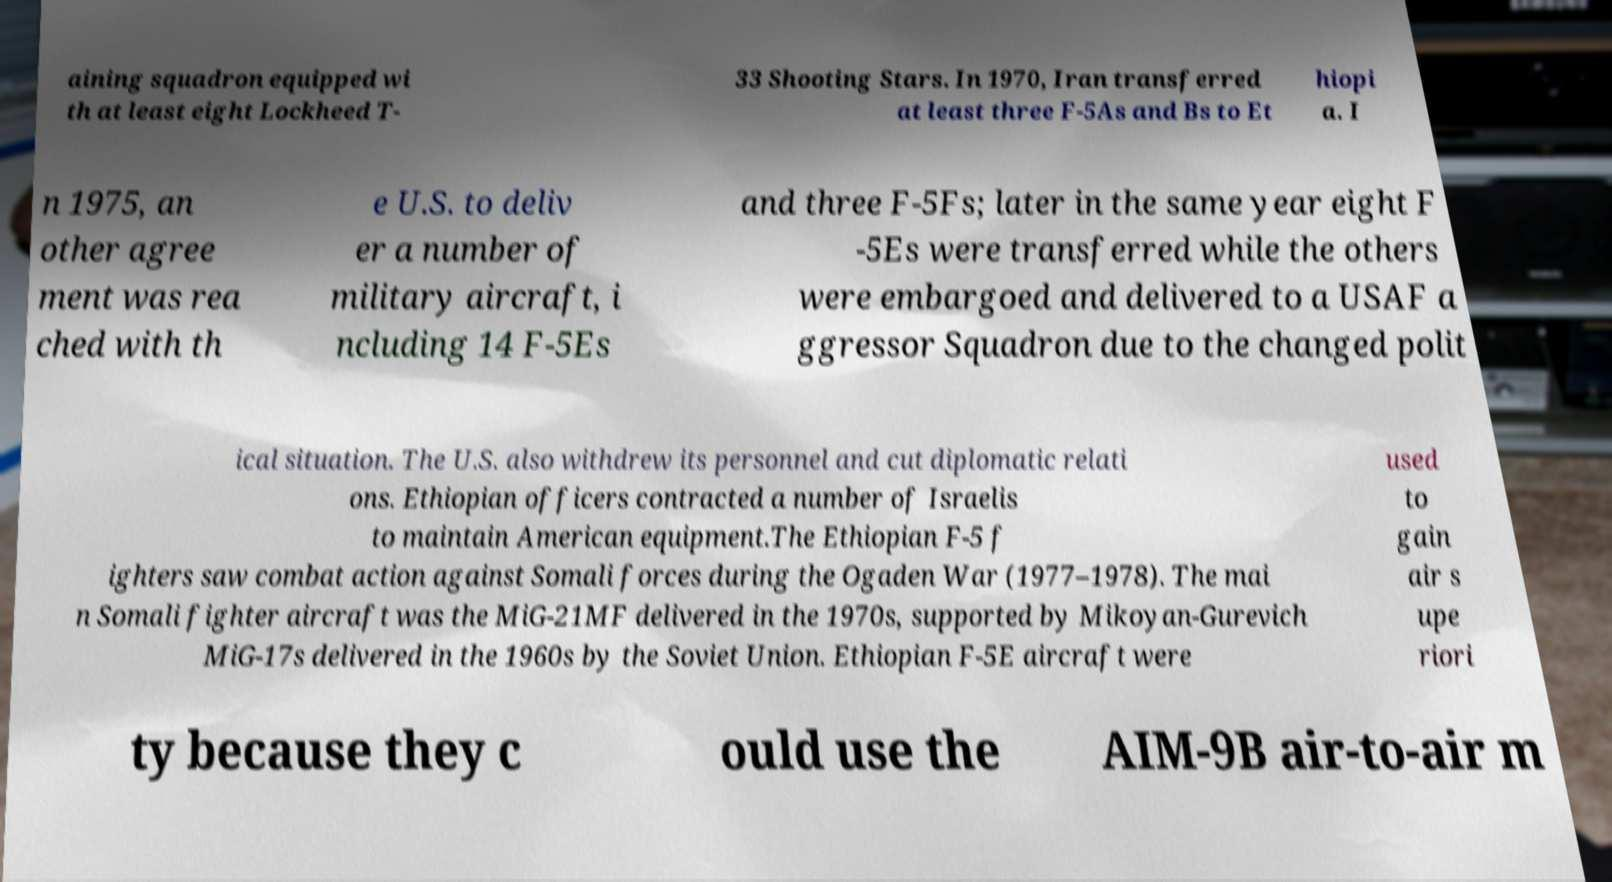Could you extract and type out the text from this image? aining squadron equipped wi th at least eight Lockheed T- 33 Shooting Stars. In 1970, Iran transferred at least three F-5As and Bs to Et hiopi a. I n 1975, an other agree ment was rea ched with th e U.S. to deliv er a number of military aircraft, i ncluding 14 F-5Es and three F-5Fs; later in the same year eight F -5Es were transferred while the others were embargoed and delivered to a USAF a ggressor Squadron due to the changed polit ical situation. The U.S. also withdrew its personnel and cut diplomatic relati ons. Ethiopian officers contracted a number of Israelis to maintain American equipment.The Ethiopian F-5 f ighters saw combat action against Somali forces during the Ogaden War (1977–1978). The mai n Somali fighter aircraft was the MiG-21MF delivered in the 1970s, supported by Mikoyan-Gurevich MiG-17s delivered in the 1960s by the Soviet Union. Ethiopian F-5E aircraft were used to gain air s upe riori ty because they c ould use the AIM-9B air-to-air m 